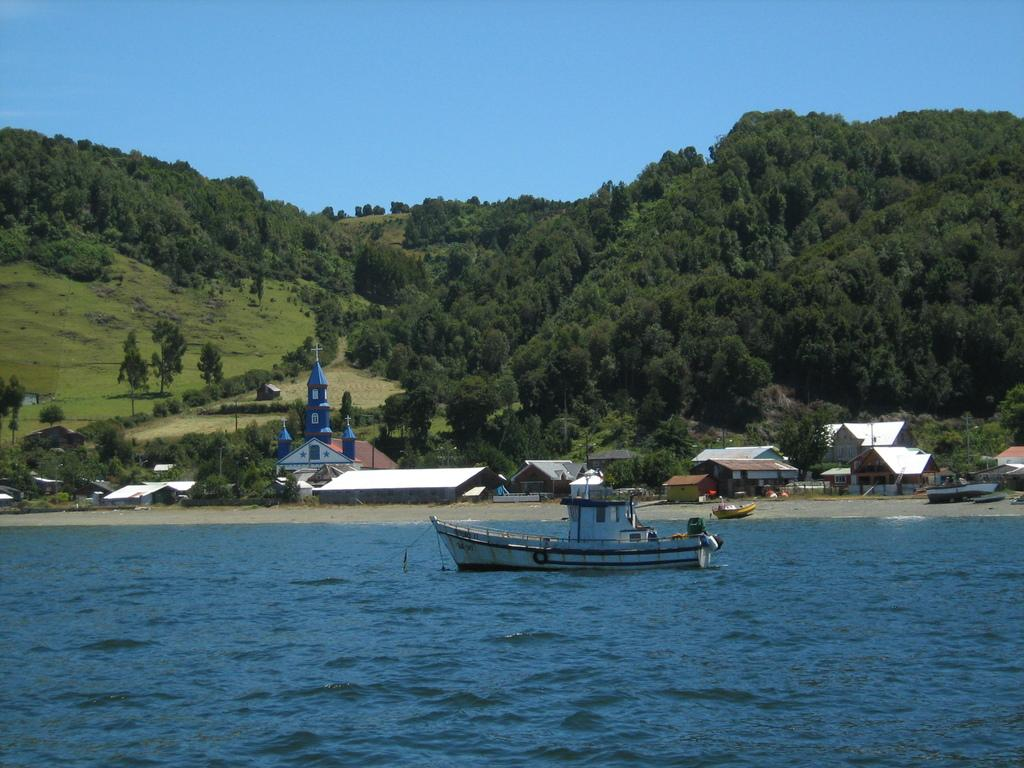What is the main subject of the image? The main subject of the image is water. What is on the water in the image? There is a boat on the water in the image. What can be seen in the background of the image? In the background of the image, there are sheds, trees, hills, and the sky. What type of bird is sitting on the shop in the image? There is no bird or shop present in the image. What color is the skin of the person in the image? There are no people or skin visible in the image. 